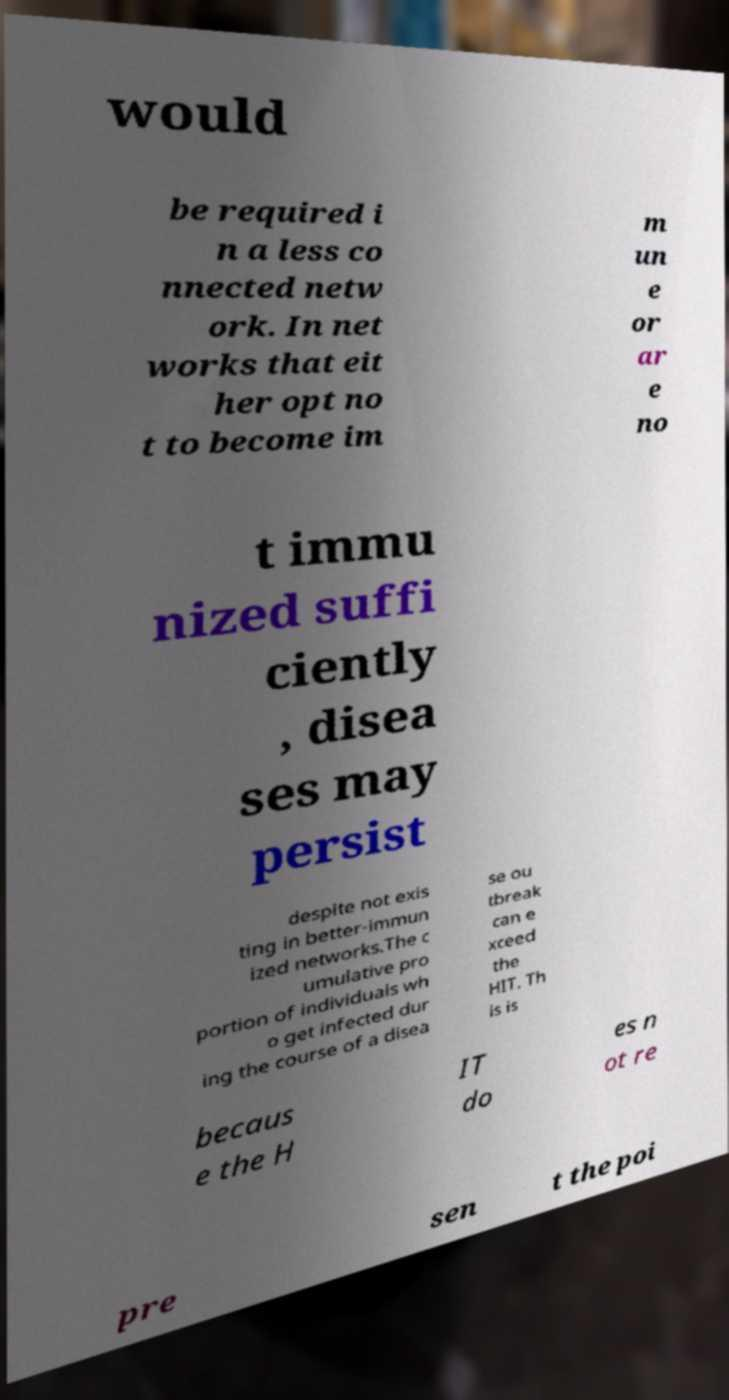Could you extract and type out the text from this image? would be required i n a less co nnected netw ork. In net works that eit her opt no t to become im m un e or ar e no t immu nized suffi ciently , disea ses may persist despite not exis ting in better-immun ized networks.The c umulative pro portion of individuals wh o get infected dur ing the course of a disea se ou tbreak can e xceed the HIT. Th is is becaus e the H IT do es n ot re pre sen t the poi 